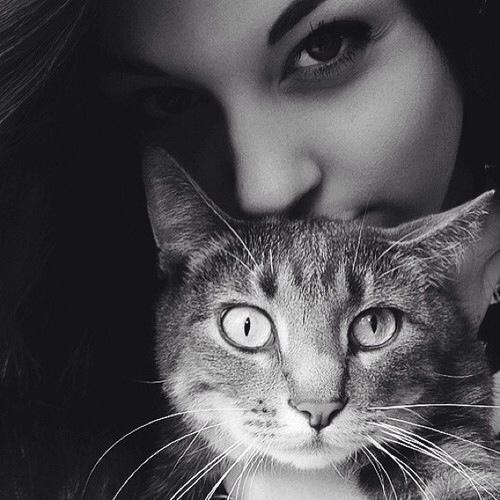How many eyes does the cat have?
Give a very brief answer. 2. How many people are visible?
Give a very brief answer. 1. 